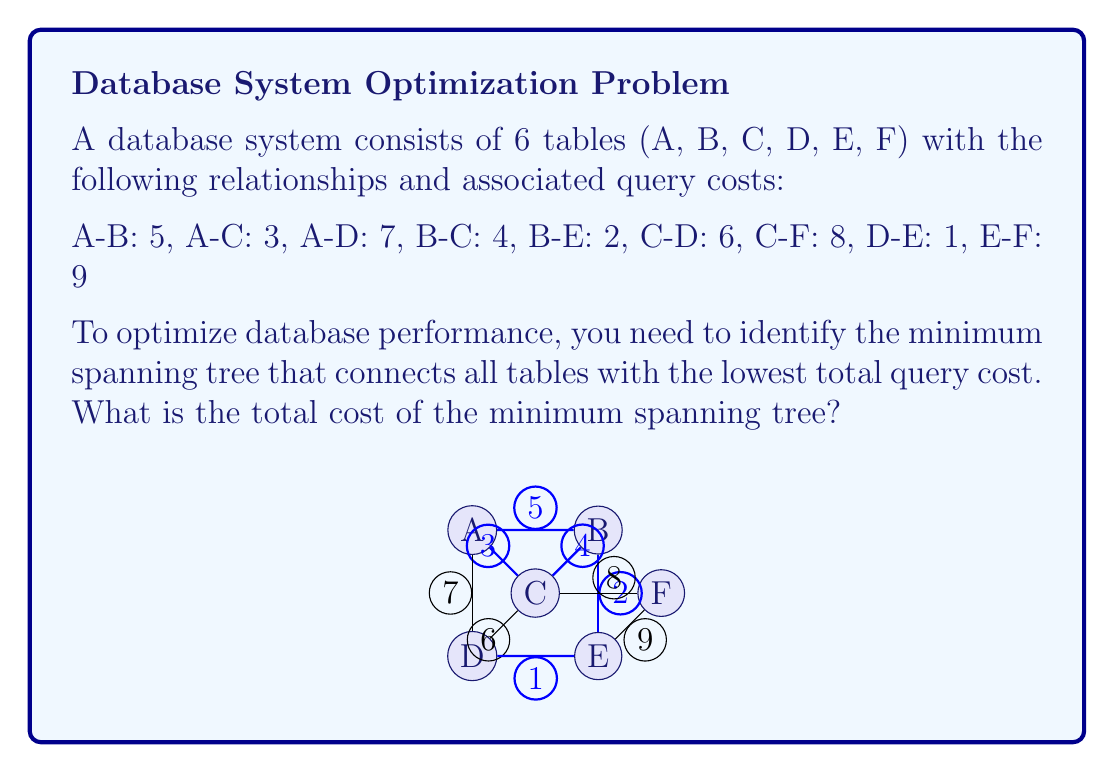Could you help me with this problem? To find the minimum spanning tree, we can use Kruskal's algorithm:

1) Sort all edges by weight (cost) in ascending order:
   D-E: 1, B-E: 2, A-C: 3, B-C: 4, A-B: 5, C-D: 6, A-D: 7, C-F: 8, E-F: 9

2) Start with an empty set of edges and add edges one by one:

   - Add D-E (cost 1)
   - Add B-E (cost 2)
   - Add A-C (cost 3)
   - Add B-C (cost 4)
   - Add C-F (cost 8)

3) Stop when we have 5 edges (for 6 vertices, we need n-1 = 5 edges)

The resulting minimum spanning tree has the following edges:
D-E, B-E, A-C, B-C, C-F

To calculate the total cost, we sum the costs of these edges:

$$ \text{Total Cost} = 1 + 2 + 3 + 4 + 8 = 18 $$

This minimum spanning tree ensures that all tables are connected with the lowest possible total query cost, optimizing the database performance for joins and related operations across these tables.
Answer: The total cost of the minimum spanning tree is 18. 